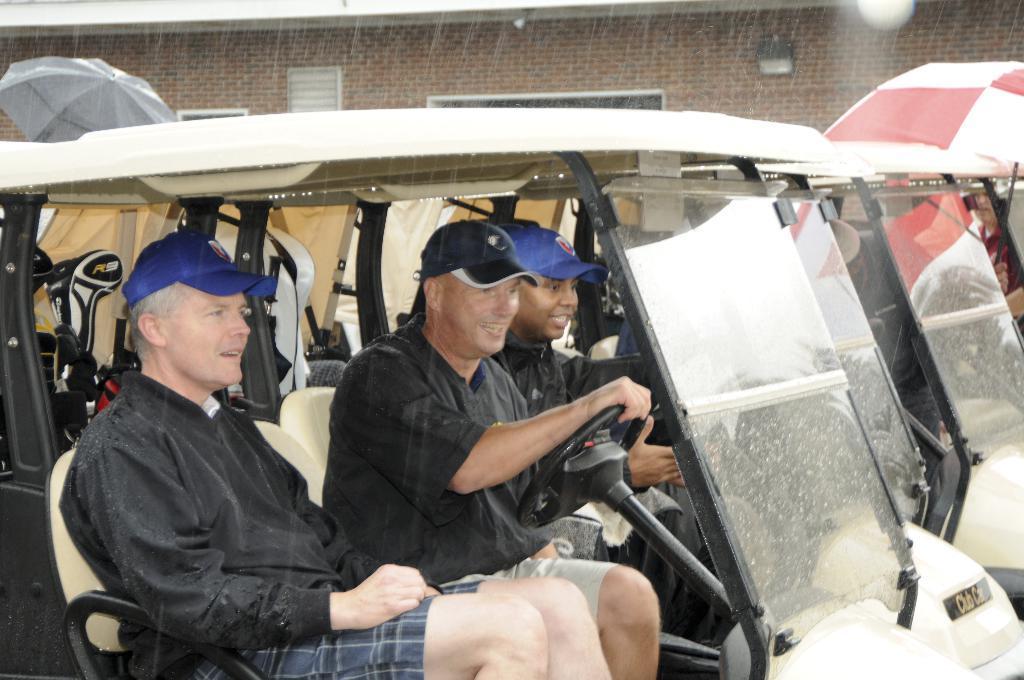How would you summarize this image in a sentence or two? In this image we can see the people in the vehicle. We can also see the umbrellas and also the rain. In the background we can see the building. 